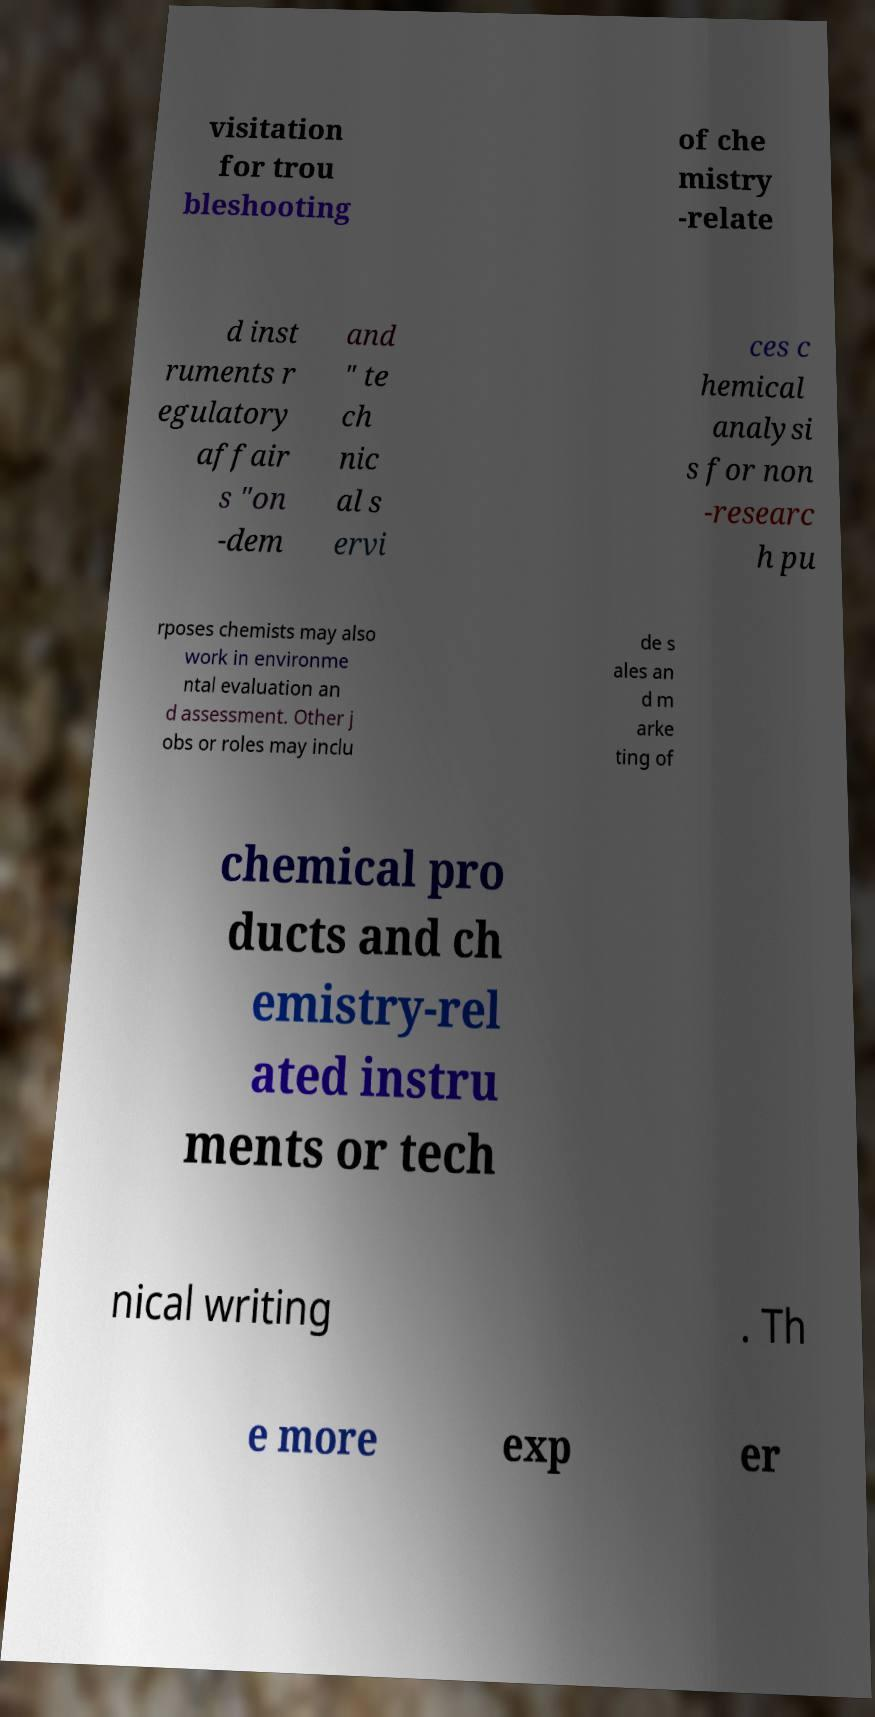Can you accurately transcribe the text from the provided image for me? visitation for trou bleshooting of che mistry -relate d inst ruments r egulatory affair s "on -dem and " te ch nic al s ervi ces c hemical analysi s for non -researc h pu rposes chemists may also work in environme ntal evaluation an d assessment. Other j obs or roles may inclu de s ales an d m arke ting of chemical pro ducts and ch emistry-rel ated instru ments or tech nical writing . Th e more exp er 